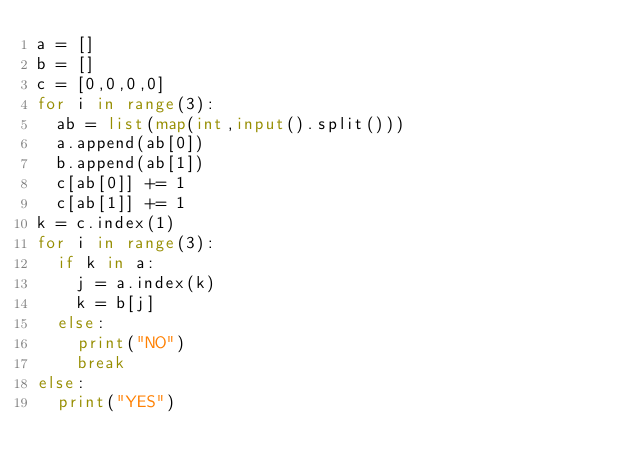Convert code to text. <code><loc_0><loc_0><loc_500><loc_500><_Python_>a = []
b = []
c = [0,0,0,0]
for i in range(3):
  ab = list(map(int,input().split()))
  a.append(ab[0])
  b.append(ab[1])
  c[ab[0]] += 1
  c[ab[1]] += 1
k = c.index(1)
for i in range(3):
  if k in a:
    j = a.index(k)
    k = b[j]
  else:
    print("NO")
    break
else:
  print("YES")</code> 